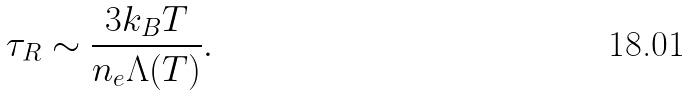Convert formula to latex. <formula><loc_0><loc_0><loc_500><loc_500>\tau _ { R } \sim \frac { 3 k _ { B } T } { n _ { e } \Lambda ( T ) } .</formula> 